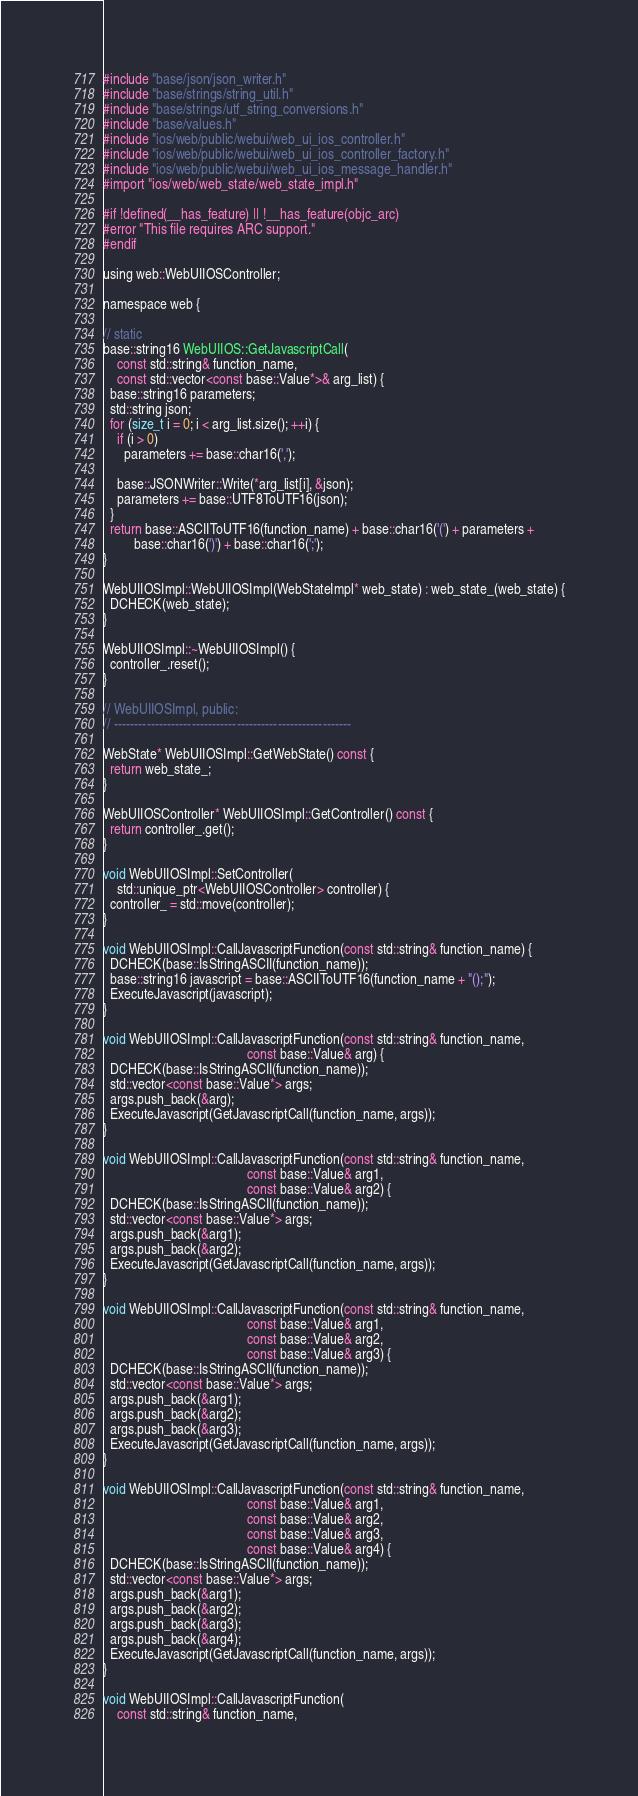<code> <loc_0><loc_0><loc_500><loc_500><_ObjectiveC_>
#include "base/json/json_writer.h"
#include "base/strings/string_util.h"
#include "base/strings/utf_string_conversions.h"
#include "base/values.h"
#include "ios/web/public/webui/web_ui_ios_controller.h"
#include "ios/web/public/webui/web_ui_ios_controller_factory.h"
#include "ios/web/public/webui/web_ui_ios_message_handler.h"
#import "ios/web/web_state/web_state_impl.h"

#if !defined(__has_feature) || !__has_feature(objc_arc)
#error "This file requires ARC support."
#endif

using web::WebUIIOSController;

namespace web {

// static
base::string16 WebUIIOS::GetJavascriptCall(
    const std::string& function_name,
    const std::vector<const base::Value*>& arg_list) {
  base::string16 parameters;
  std::string json;
  for (size_t i = 0; i < arg_list.size(); ++i) {
    if (i > 0)
      parameters += base::char16(',');

    base::JSONWriter::Write(*arg_list[i], &json);
    parameters += base::UTF8ToUTF16(json);
  }
  return base::ASCIIToUTF16(function_name) + base::char16('(') + parameters +
         base::char16(')') + base::char16(';');
}

WebUIIOSImpl::WebUIIOSImpl(WebStateImpl* web_state) : web_state_(web_state) {
  DCHECK(web_state);
}

WebUIIOSImpl::~WebUIIOSImpl() {
  controller_.reset();
}

// WebUIIOSImpl, public:
// ----------------------------------------------------------

WebState* WebUIIOSImpl::GetWebState() const {
  return web_state_;
}

WebUIIOSController* WebUIIOSImpl::GetController() const {
  return controller_.get();
}

void WebUIIOSImpl::SetController(
    std::unique_ptr<WebUIIOSController> controller) {
  controller_ = std::move(controller);
}

void WebUIIOSImpl::CallJavascriptFunction(const std::string& function_name) {
  DCHECK(base::IsStringASCII(function_name));
  base::string16 javascript = base::ASCIIToUTF16(function_name + "();");
  ExecuteJavascript(javascript);
}

void WebUIIOSImpl::CallJavascriptFunction(const std::string& function_name,
                                          const base::Value& arg) {
  DCHECK(base::IsStringASCII(function_name));
  std::vector<const base::Value*> args;
  args.push_back(&arg);
  ExecuteJavascript(GetJavascriptCall(function_name, args));
}

void WebUIIOSImpl::CallJavascriptFunction(const std::string& function_name,
                                          const base::Value& arg1,
                                          const base::Value& arg2) {
  DCHECK(base::IsStringASCII(function_name));
  std::vector<const base::Value*> args;
  args.push_back(&arg1);
  args.push_back(&arg2);
  ExecuteJavascript(GetJavascriptCall(function_name, args));
}

void WebUIIOSImpl::CallJavascriptFunction(const std::string& function_name,
                                          const base::Value& arg1,
                                          const base::Value& arg2,
                                          const base::Value& arg3) {
  DCHECK(base::IsStringASCII(function_name));
  std::vector<const base::Value*> args;
  args.push_back(&arg1);
  args.push_back(&arg2);
  args.push_back(&arg3);
  ExecuteJavascript(GetJavascriptCall(function_name, args));
}

void WebUIIOSImpl::CallJavascriptFunction(const std::string& function_name,
                                          const base::Value& arg1,
                                          const base::Value& arg2,
                                          const base::Value& arg3,
                                          const base::Value& arg4) {
  DCHECK(base::IsStringASCII(function_name));
  std::vector<const base::Value*> args;
  args.push_back(&arg1);
  args.push_back(&arg2);
  args.push_back(&arg3);
  args.push_back(&arg4);
  ExecuteJavascript(GetJavascriptCall(function_name, args));
}

void WebUIIOSImpl::CallJavascriptFunction(
    const std::string& function_name,</code> 